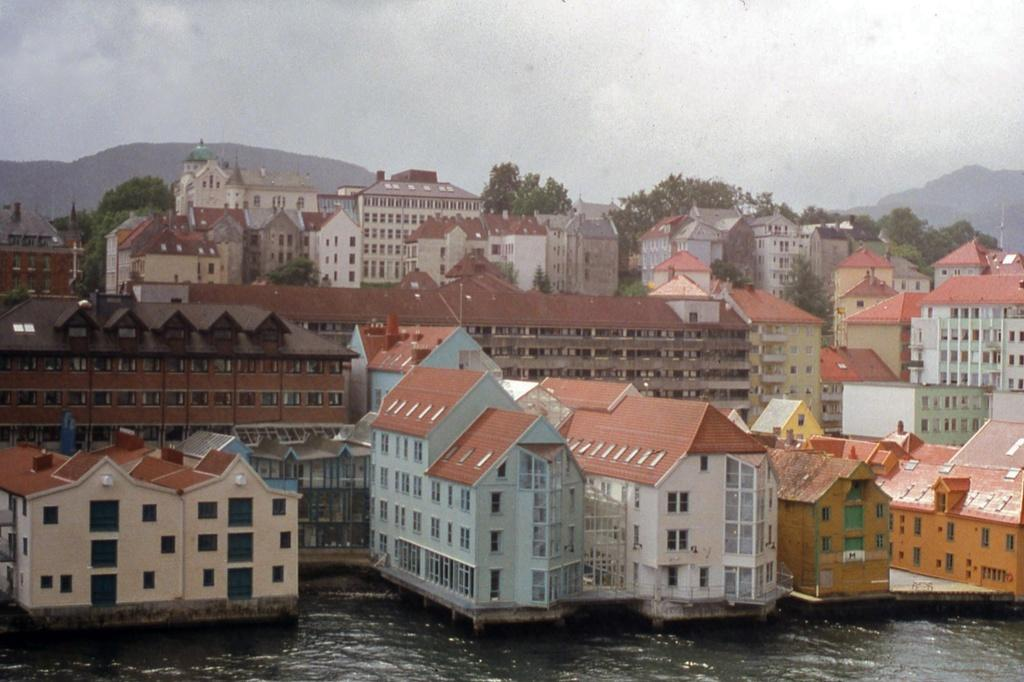What is located at the bottom of the image? There is water at the bottom of the image. What can be seen in the middle of the image? There are buildings and trees in the middle of the image. What is visible at the top of the image? The sky is visible at the top of the image. How many pets are visible in the image? There are no pets present in the image. What type of minister can be seen in the image? There is no minister present in the image. 